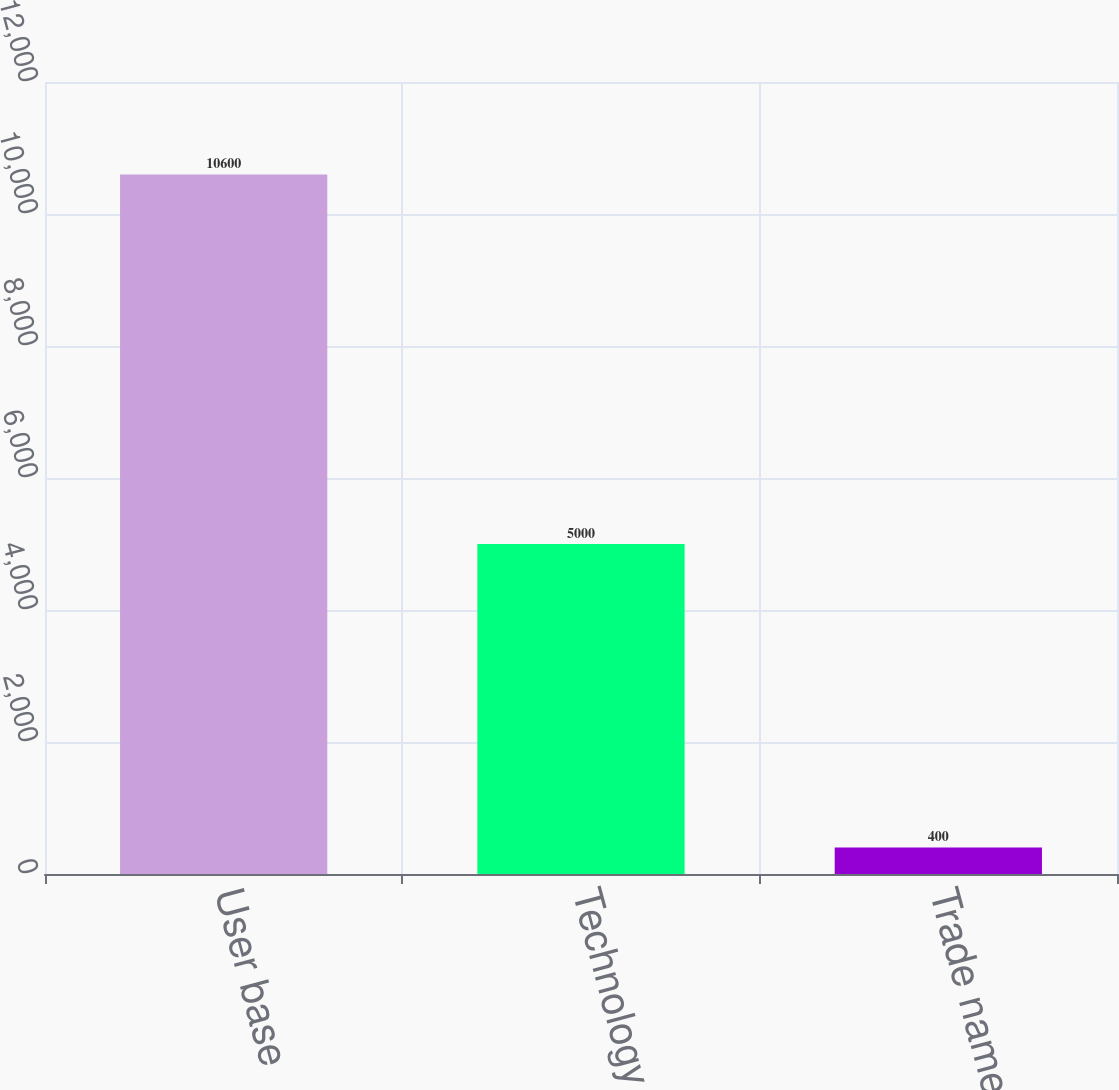Convert chart. <chart><loc_0><loc_0><loc_500><loc_500><bar_chart><fcel>User base<fcel>Technology<fcel>Trade name<nl><fcel>10600<fcel>5000<fcel>400<nl></chart> 